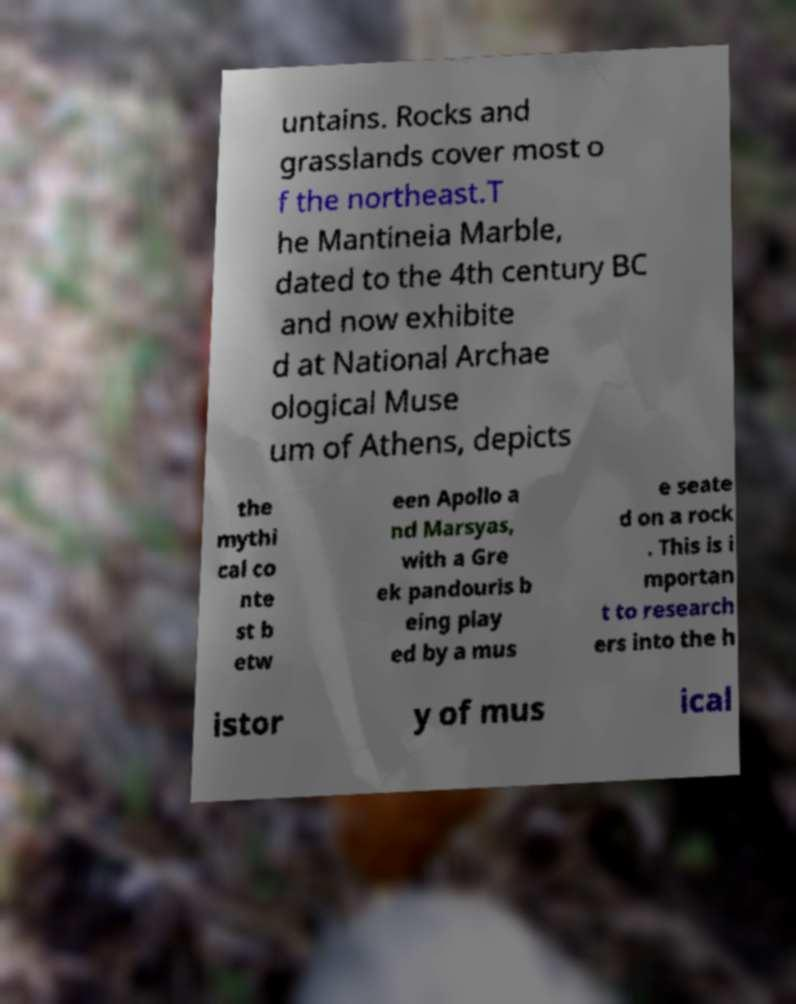Could you extract and type out the text from this image? untains. Rocks and grasslands cover most o f the northeast.T he Mantineia Marble, dated to the 4th century BC and now exhibite d at National Archae ological Muse um of Athens, depicts the mythi cal co nte st b etw een Apollo a nd Marsyas, with a Gre ek pandouris b eing play ed by a mus e seate d on a rock . This is i mportan t to research ers into the h istor y of mus ical 